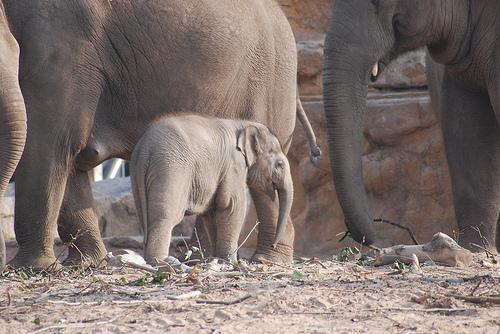How many baby elephants are there?
Give a very brief answer. 1. 